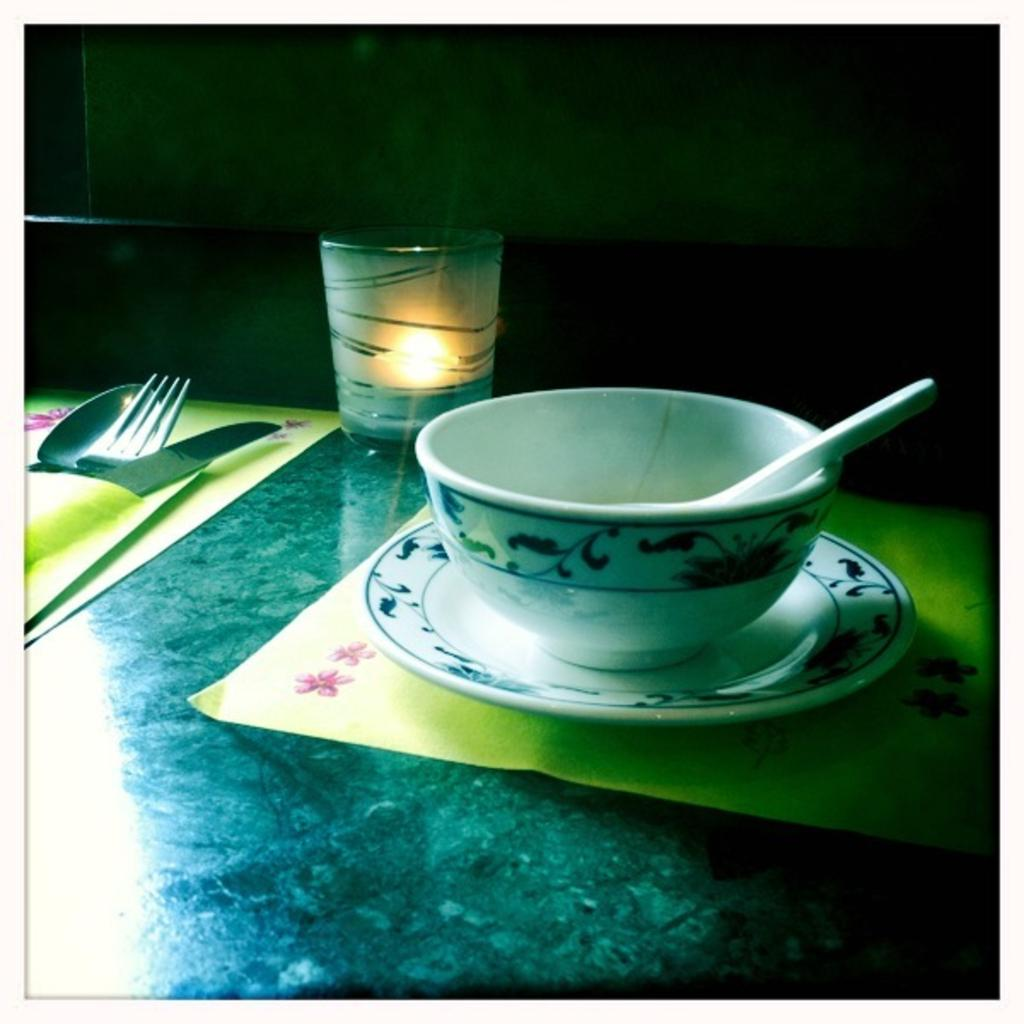What is on the table in the image? There is a bowl, a candle, a spoon, a fork, and a knife on the table in the image. What might be used for eating in the image? The spoon and fork on the table might be used for eating. What is the purpose of the candle on the table? The purpose of the candle on the table is likely for lighting or decoration. What is the bowl on the table used for? The bowl on the table might be used for holding food or other items. What type of insect can be seen crawling on the plough in the image? There is no plough or insect present in the image. 